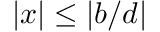<formula> <loc_0><loc_0><loc_500><loc_500>| x | \leq | b / d |</formula> 